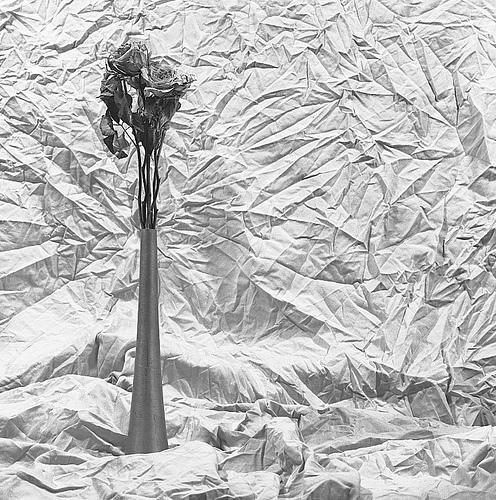Is this a color photo?
Concise answer only. No. Is this plant alive?
Keep it brief. No. Is there fabric in this picture?
Give a very brief answer. Yes. 